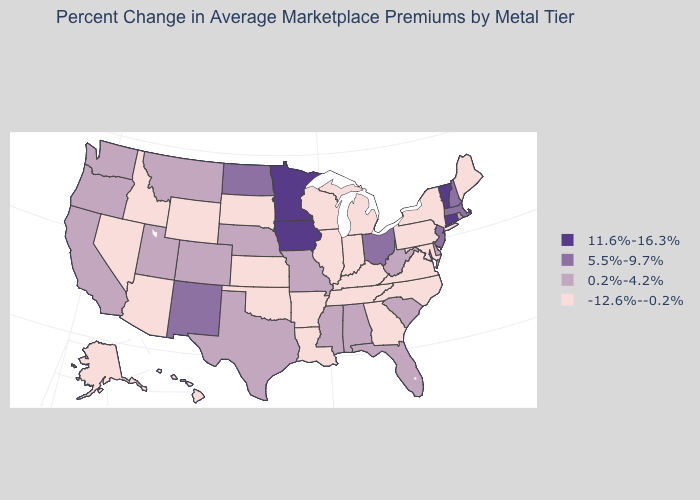Which states have the lowest value in the MidWest?
Be succinct. Illinois, Indiana, Kansas, Michigan, South Dakota, Wisconsin. Which states have the highest value in the USA?
Answer briefly. Connecticut, Iowa, Minnesota, Vermont. Among the states that border Washington , does Oregon have the highest value?
Concise answer only. Yes. What is the highest value in states that border Louisiana?
Answer briefly. 0.2%-4.2%. Among the states that border New Hampshire , does Vermont have the highest value?
Give a very brief answer. Yes. Does New Mexico have the highest value in the West?
Be succinct. Yes. Does Michigan have the highest value in the MidWest?
Quick response, please. No. Among the states that border Idaho , which have the highest value?
Keep it brief. Montana, Oregon, Utah, Washington. What is the highest value in states that border Mississippi?
Answer briefly. 0.2%-4.2%. Name the states that have a value in the range 11.6%-16.3%?
Answer briefly. Connecticut, Iowa, Minnesota, Vermont. What is the value of Indiana?
Concise answer only. -12.6%--0.2%. Name the states that have a value in the range 5.5%-9.7%?
Keep it brief. Massachusetts, New Hampshire, New Jersey, New Mexico, North Dakota, Ohio. Does Minnesota have the lowest value in the USA?
Short answer required. No. Which states have the lowest value in the Northeast?
Give a very brief answer. Maine, New York, Pennsylvania. What is the value of South Carolina?
Quick response, please. 0.2%-4.2%. 